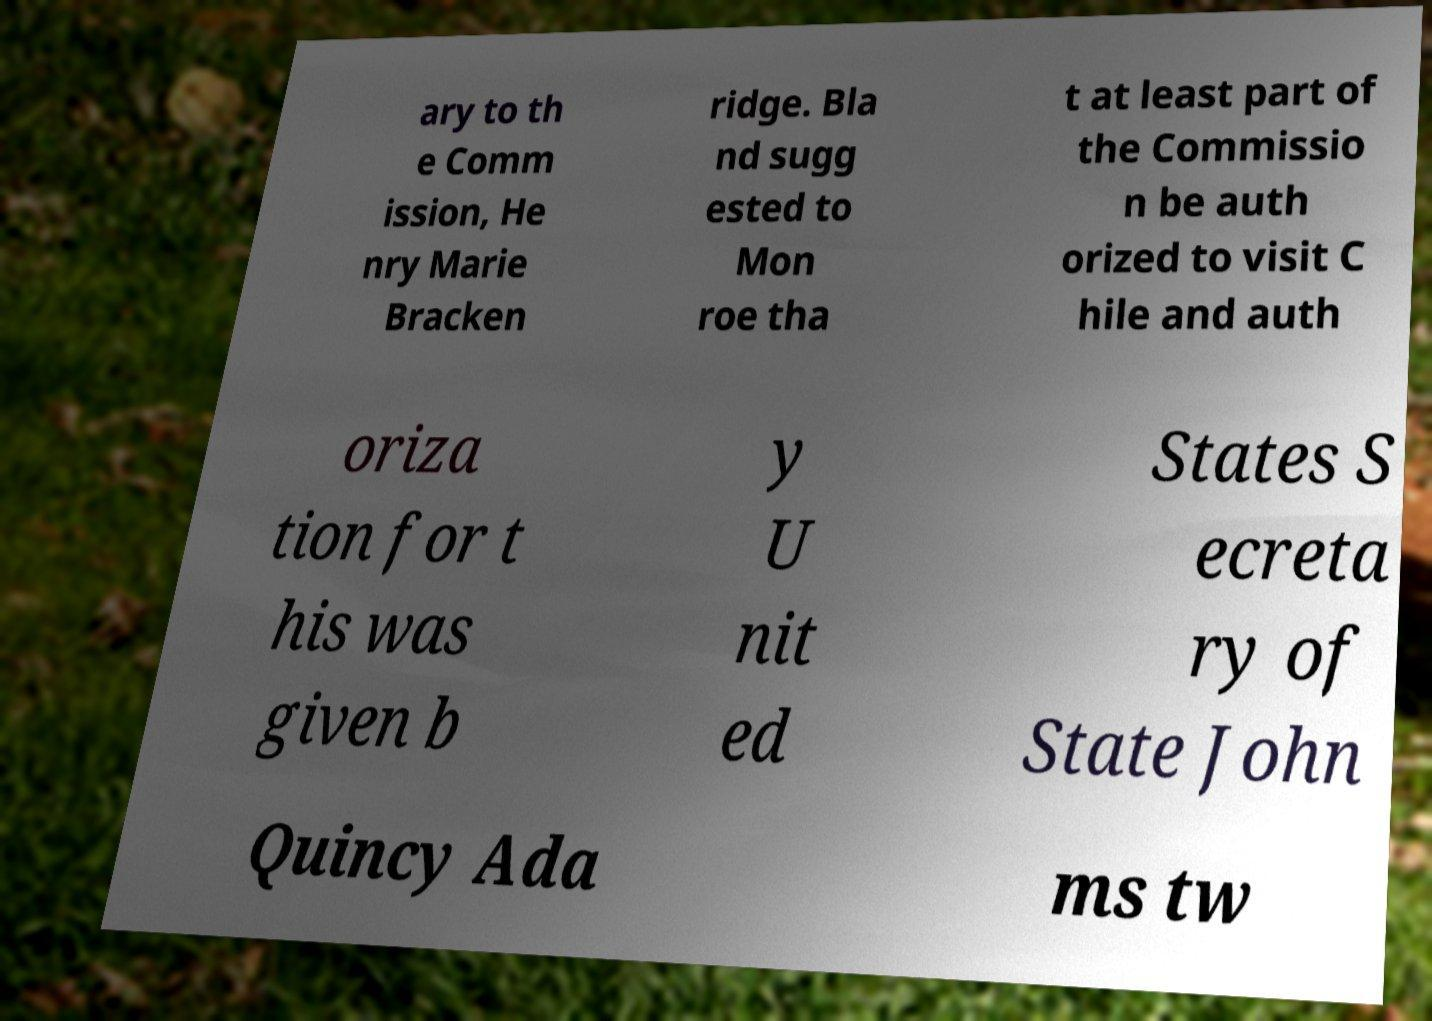Can you read and provide the text displayed in the image?This photo seems to have some interesting text. Can you extract and type it out for me? ary to th e Comm ission, He nry Marie Bracken ridge. Bla nd sugg ested to Mon roe tha t at least part of the Commissio n be auth orized to visit C hile and auth oriza tion for t his was given b y U nit ed States S ecreta ry of State John Quincy Ada ms tw 